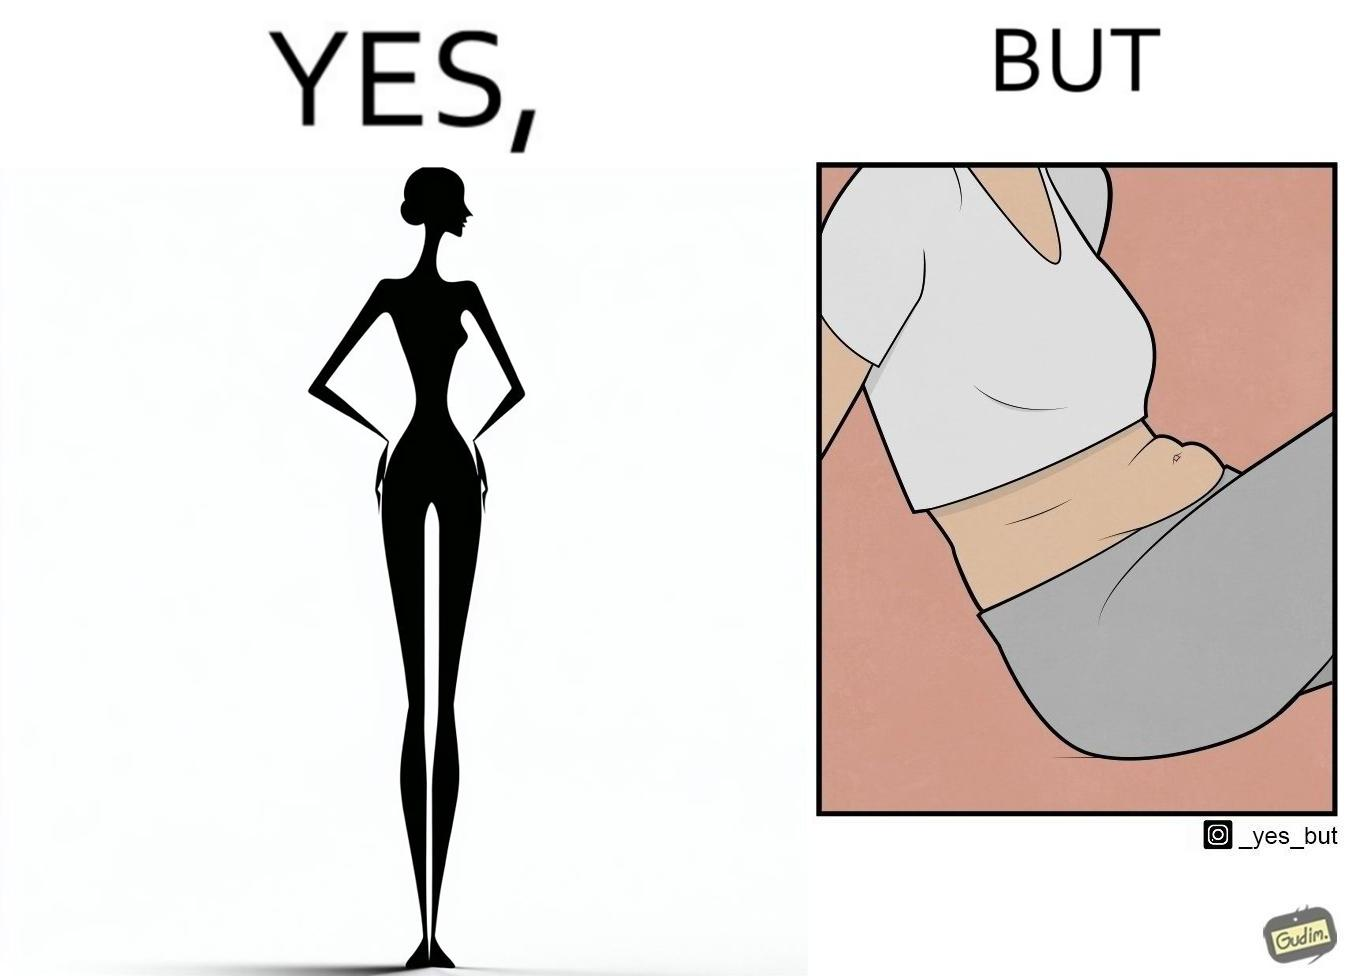Describe the satirical element in this image. the image is funny, as from the front, the woman is apparently slim, but she looks chubby from the side. 